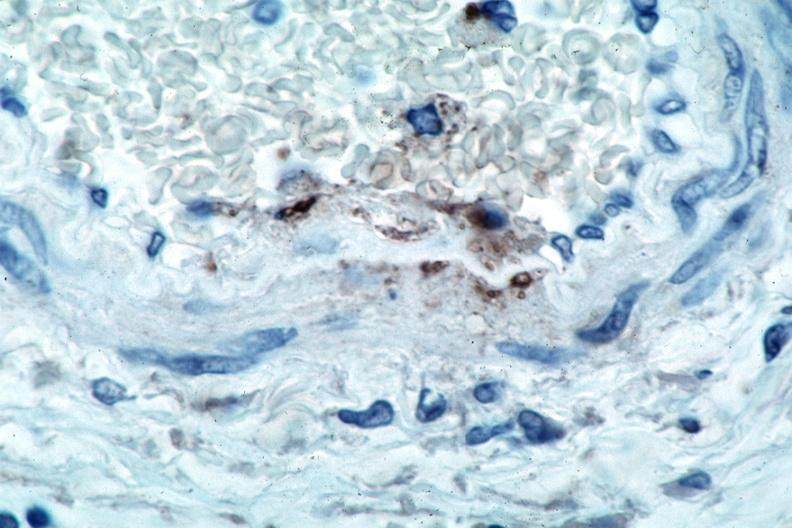where is this from?
Answer the question using a single word or phrase. Vasculature 